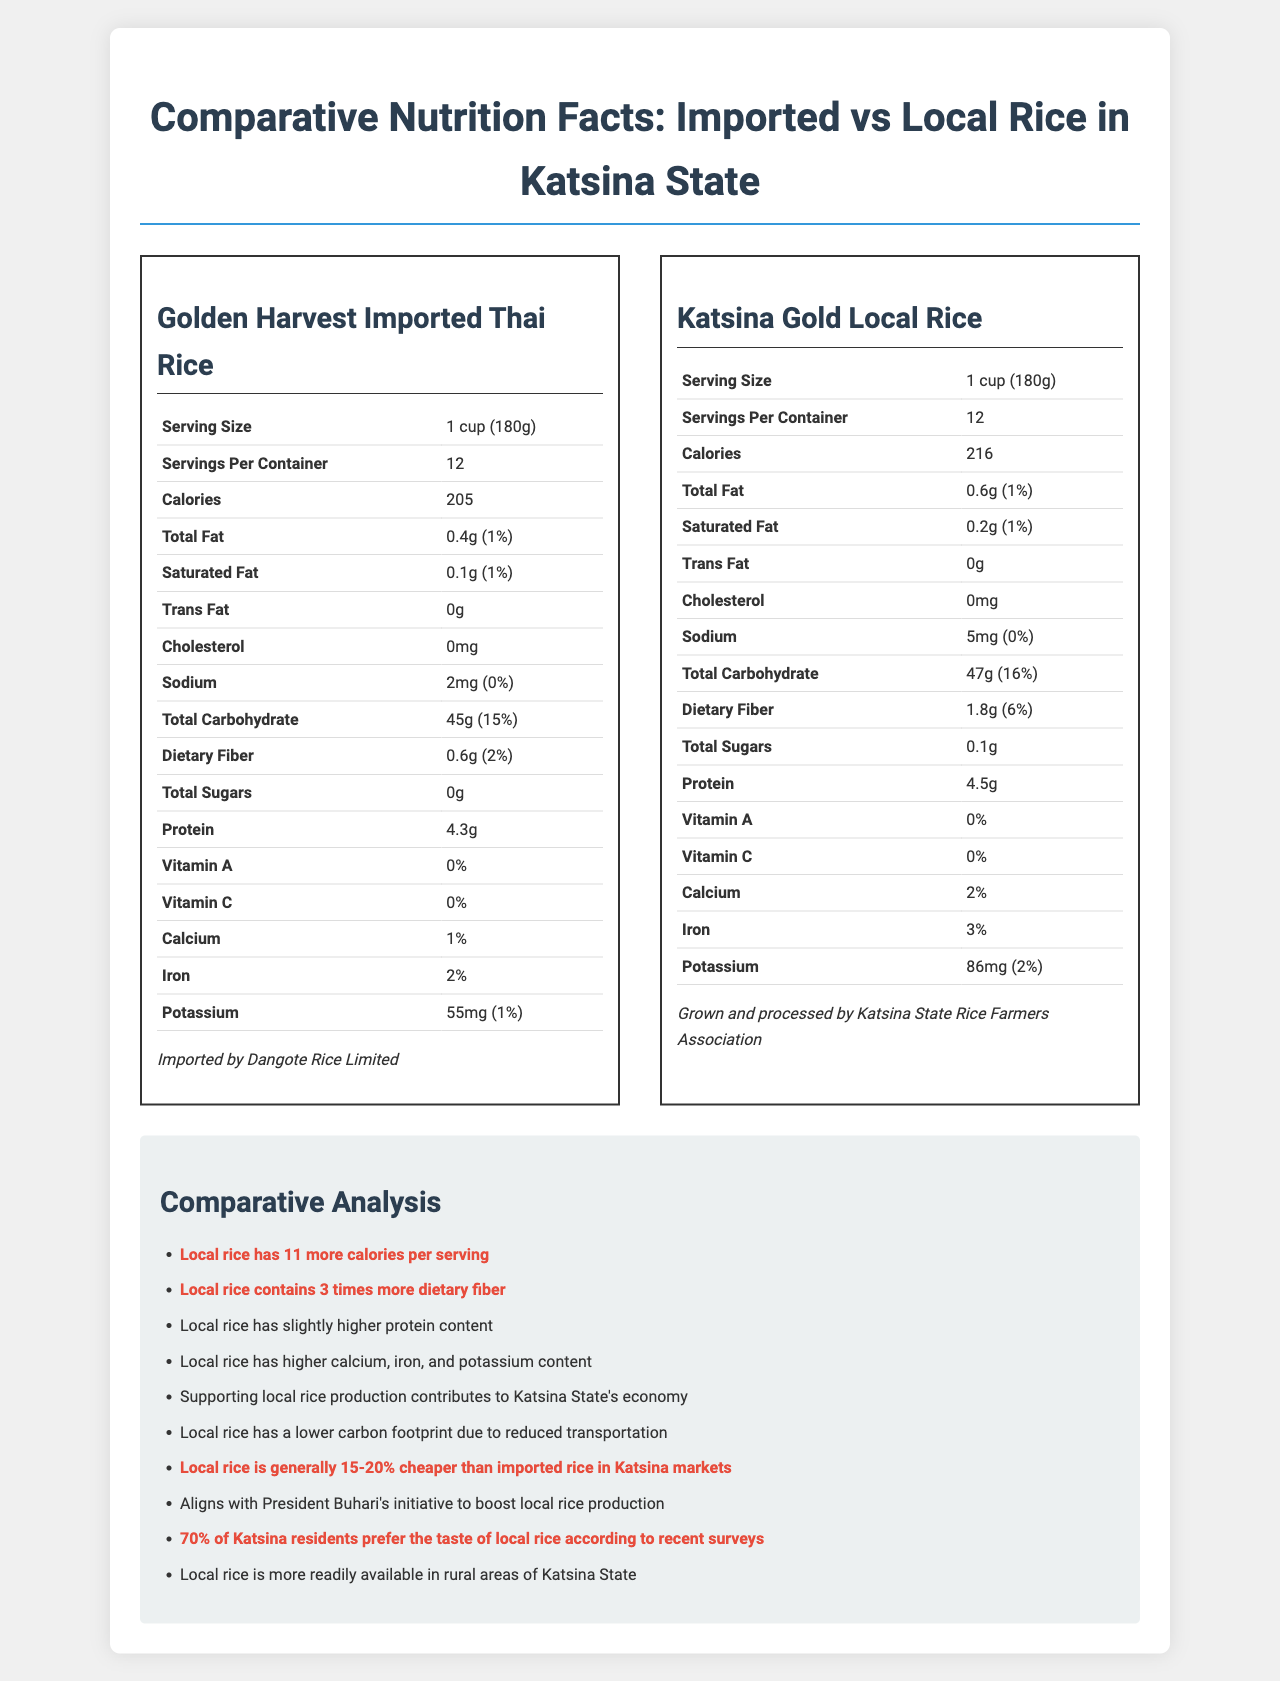what is the serving size of Golden Harvest Imported Thai Rice? The serving size is explicitly mentioned in the nutrition facts label of Golden Harvest Imported Thai Rice under the section "Serving Size".
Answer: 1 cup (180g) how many calories are there per serving in the Katsina Gold Local Rice? The calories per serving are mentioned directly in the nutrition facts label under the "Calories" section of Katsina Gold Local Rice.
Answer: 216 how much dietary fiber does locally grown rice contain? The dietary fiber content for Katsina Gold Local Rice is listed as 1.8g under the "Dietary Fiber" section in its nutrition facts label.
Answer: 1.8g What is the percentage daily value of iron in the imported rice? The percentage daily value of iron in Golden Harvest Imported Thai Rice is mentioned as 2% in its nutrition facts label under the "Iron" section.
Answer: 2% Which rice has more protein per serving? Katsina Gold Local Rice has 4.5g of protein per serving, whereas Golden Harvest Imported Thai Rice has 4.3g.
Answer: Katsina Gold Local Rice which rice has a higher sodium content? A. Golden Harvest Imported Thai Rice B. Katsina Gold Local Rice Katsina Gold Local Rice has 5mg of sodium compared to Golden Harvest Imported Thai Rice which has 2mg.
Answer: B. Katsina Gold Local Rice Which of the following statements is true based on the document? I. Local rice has fewer calories than imported rice II. Local rice has more dietary fiber than imported rice III. Imported rice has more protein than local rice Only statement II is true. Local rice has 1.8g dietary fiber compared to imported rice's 0.6g. Statement I is false as local rice has more calories, and statement III is false because local rice has slightly more protein than imported rice.
Answer: II. Local rice has more dietary fiber than imported rice Does local rice contain any trans fat? The nutrition facts label for Katsina Gold Local Rice shows 0g of trans fat.
Answer: No Summarize the main differences between imported and local rice based on the document. According to the comparative analysis, Katsina Gold Local Rice has 11 more calories per serving, thrice the dietary fiber, slightly higher protein, and higher calcium, iron, and potassium content compared to Golden Harvest Imported Thai Rice. Economically, local rice supports the local economy, has a lower carbon footprint, and is generally cheaper. It also aligns with government policies promoting local production.
Answer: Local rice has higher calories, dietary fiber, protein, and mineral content, and is cheaper and more eco-friendly compared to imported rice. What are the environmental benefits of choosing local rice over imported rice? The document states that local rice has a lower carbon footprint because it doesn't require long-distance transportation, unlike imported rice.
Answer: Lower carbon footprint due to reduced transportation What is the vitamin C content in both types of rice? Both Golden Harvest Imported Thai Rice and Katsina Gold Local Rice have 0% vitamin C content, as indicated in their respective nutrition facts labels.
Answer: 0% What is the additional information given about Golden Harvest Imported Thai Rice? The document explicitly states that Golden Harvest Imported Thai Rice is imported by Dangote Rice Limited.
Answer: Imported by Dangote Rice Limited How does the dietary fiber percentage daily value of local rice compare to imported rice? The percentage daily value of dietary fiber in Katsina Gold Local Rice is 6%, while it is only 2% in Golden Harvest Imported Thai Rice.
Answer: Local rice has 6% compared to 2% in imported rice Why might someone choose Katsina Gold Local Rice over Golden Harvest Imported Thai Rice from an economic perspective? The comparative analysis points out that purchasing local rice bolsters the local economy and is cheaper by 15-20% in Katsina markets.
Answer: Local rice supports the local economy and is generally 15-20% cheaper How many servings per container does the local rice have? The nutrition facts label for Katsina Gold Local Rice indicates that there are 12 servings per container.
Answer: 12 Who processes the Katsina Gold Local Rice? The document specifies that the local rice is grown and processed by the Katsina State Rice Farmers Association.
Answer: Katsina State Rice Farmers Association Does the document mention the price of Katsina Gold Local Rice? The document provides a comparative statement that local rice is generally 15-20% cheaper than imported rice but does not mention an exact price.
Answer: Not enough information 